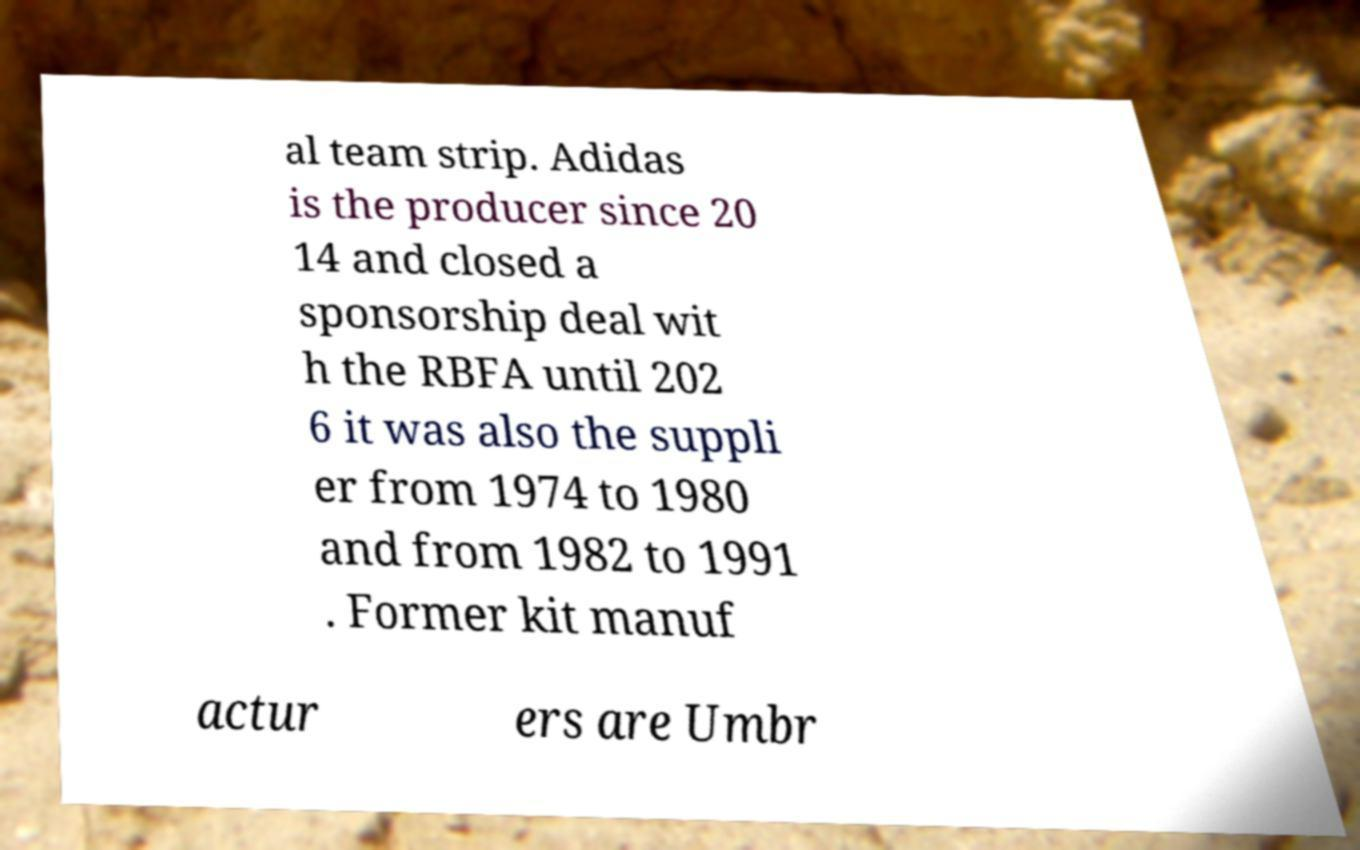Can you accurately transcribe the text from the provided image for me? al team strip. Adidas is the producer since 20 14 and closed a sponsorship deal wit h the RBFA until 202 6 it was also the suppli er from 1974 to 1980 and from 1982 to 1991 . Former kit manuf actur ers are Umbr 